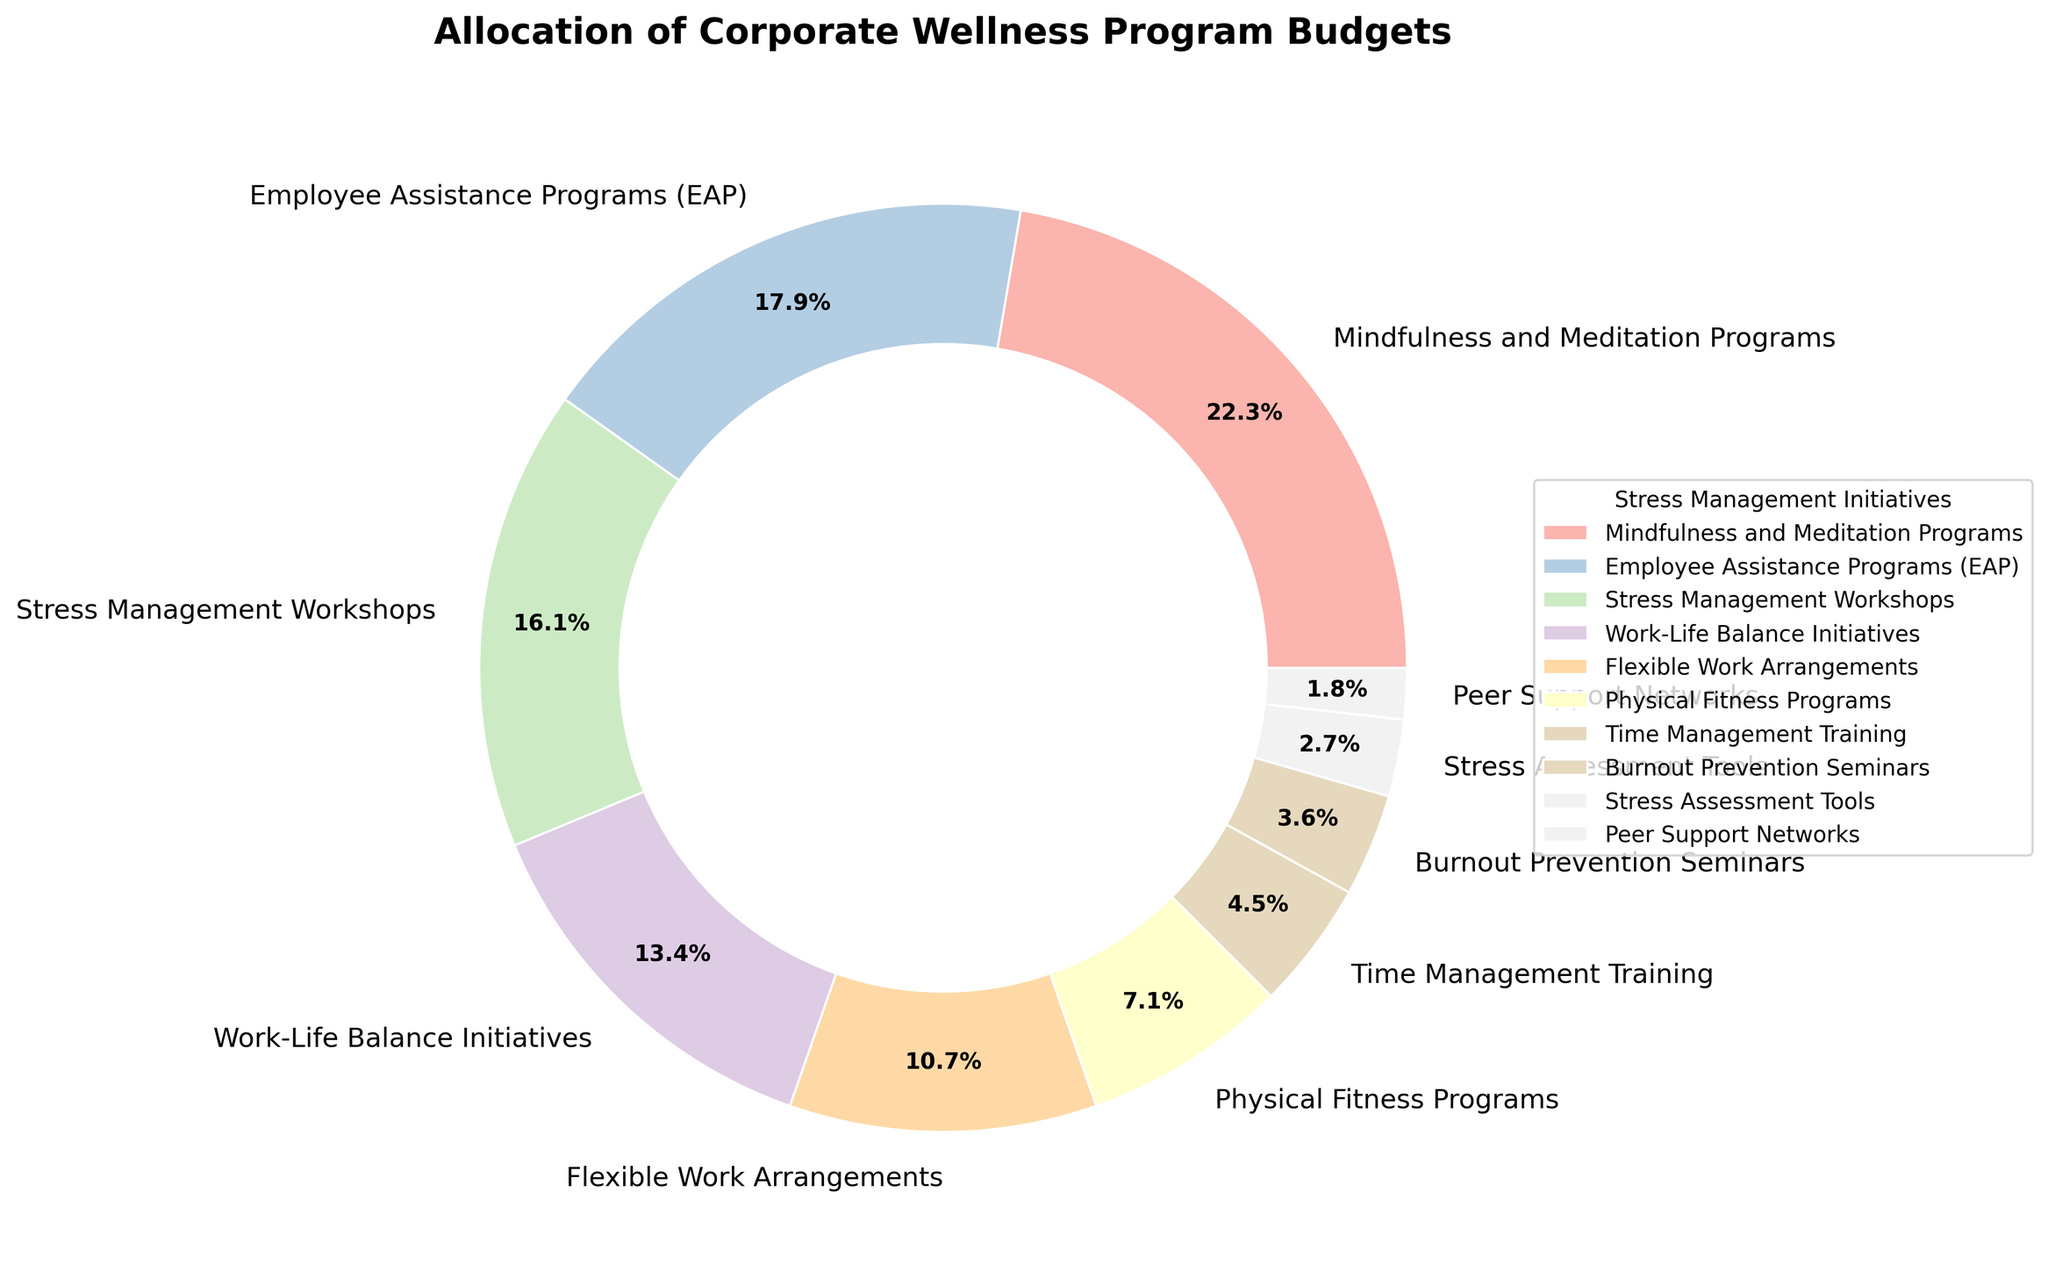What percentage of the budget is allocated to Time Management Training and Burnout Prevention Seminars combined? Add the budget percentages for Time Management Training (5%) and Burnout Prevention Seminars (4%). Thus, 5% + 4% = 9%
Answer: 9% Which initiative receives a higher budget allocation: Physical Fitness Programs or Employee Assistance Programs (EAP)? Compare the budget percentages for Physical Fitness Programs (8%) and EAP (20%). Since 20% is greater than 8%, EAP receives a higher allocation.
Answer: EAP How much more budget percentage is allocated to Mindfulness and Meditation Programs compared to Peer Support Networks? Subtract the budget percentage of Peer Support Networks (2%) from Mindfulness and Meditation Programs (25%). Thus, 25% - 2% = 23%
Answer: 23% What are the initiatives that receive less than 10% of the budget? Identify and list the initiatives with budget percentages below 10%. These are Physical Fitness Programs (8%), Time Management Training (5%), Burnout Prevention Seminars (4%), Stress Assessment Tools (3%), and Peer Support Networks (2%).
Answer: Physical Fitness Programs, Time Management Training, Burnout Prevention Seminars, Stress Assessment Tools, Peer Support Networks Is the budget allocation for Work-Life Balance Initiatives greater than the combined allocation for Stress Assessment Tools and Peer Support Networks? Compare the budget percentage of Work-Life Balance Initiatives (15%) with the combined allocation for Stress Assessment Tools (3%) and Peer Support Networks (2%). The combined allocation is 3% + 2% = 5%, which is less than 15%.
Answer: Yes What is the total budget percentage allocated to the top three stress management initiatives? The top three initiatives are Mindfulness and Meditation Programs (25%), Employee Assistance Programs (EAP) (20%), and Stress Management Workshops (18%). The total is 25% + 20% + 18% = 63%.
Answer: 63% Which color is used to represent the Flexible Work Arrangements initiative in the pie chart? Find the color associated with Flexible Work Arrangements in the chart. Based on the visualization, describe the color, which might be a soft pastel shade.
Answer: [Note: The exact color would need to be visually identified, but usually a pastel tone] Are there more initiatives allocated at least 10% of the budget or less than 10%? Count the initiatives with at least 10% budget and those with less than 10%. There are 5 initiatives with at least 10%: Mindfulness and Meditation Programs, EAP, Stress Management Workshops, Work-Life Balance Initiatives, and Flexible Work Arrangements. There are 6 with less than 10%: Physical Fitness Programs, Time Management Training, Burnout Prevention Seminars, Stress Assessment Tools, and Peer Support Networks. There are more initiatives with less than 10% allocation.
Answer: Less than 10% 